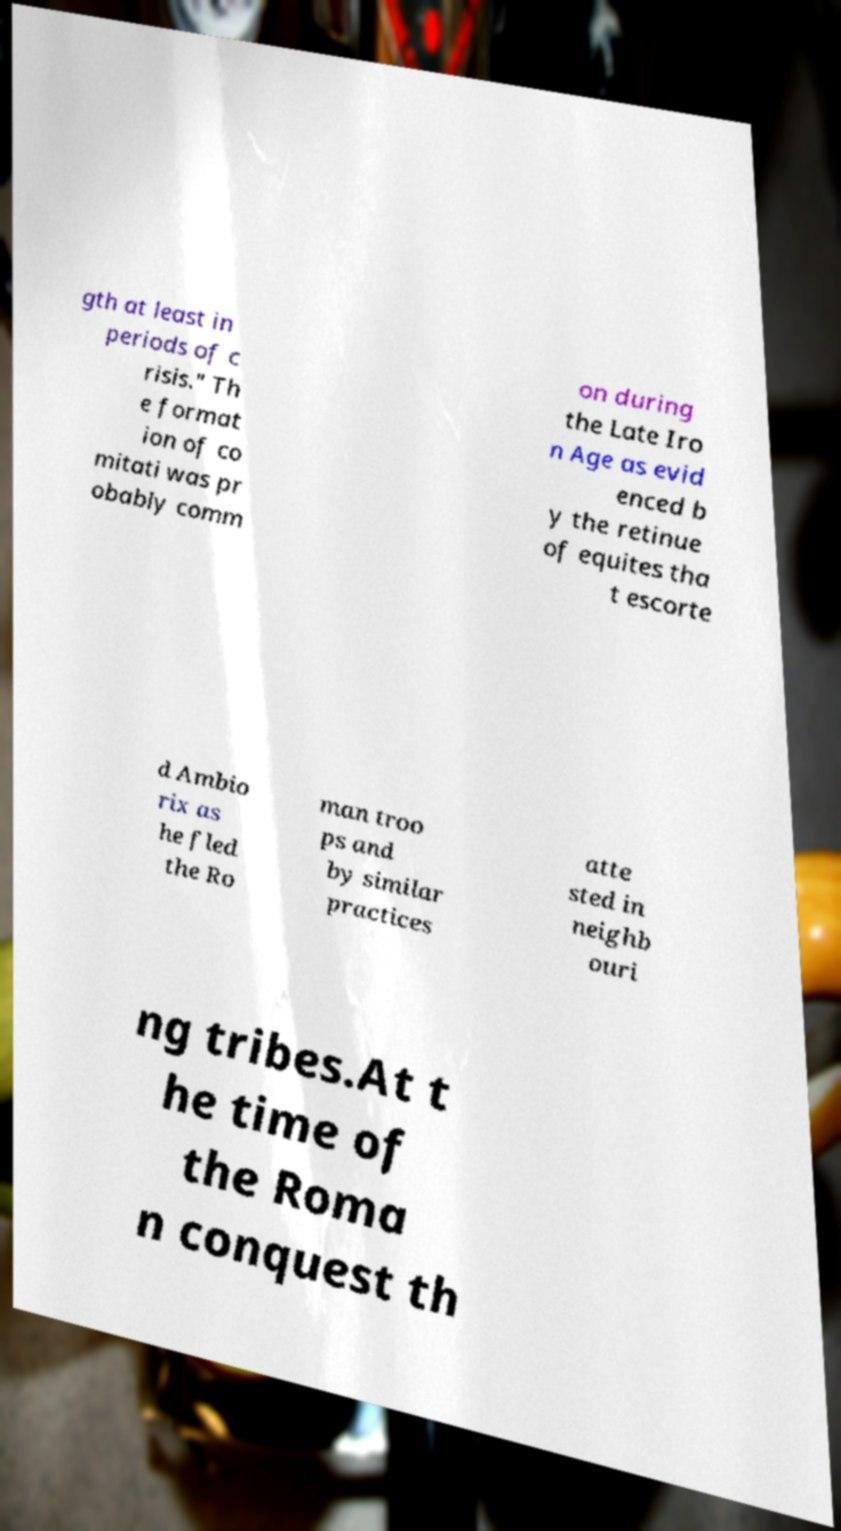Can you accurately transcribe the text from the provided image for me? gth at least in periods of c risis." Th e format ion of co mitati was pr obably comm on during the Late Iro n Age as evid enced b y the retinue of equites tha t escorte d Ambio rix as he fled the Ro man troo ps and by similar practices atte sted in neighb ouri ng tribes.At t he time of the Roma n conquest th 